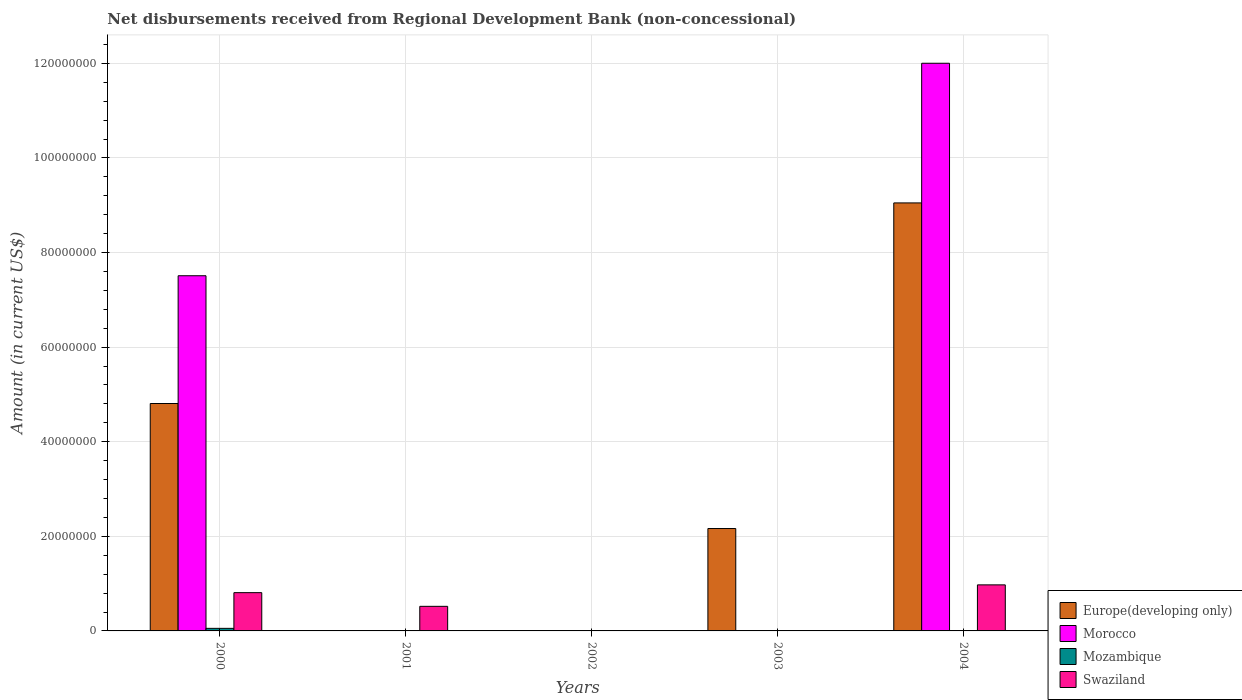How many different coloured bars are there?
Your answer should be very brief. 4. Are the number of bars per tick equal to the number of legend labels?
Your answer should be compact. No. How many bars are there on the 3rd tick from the left?
Keep it short and to the point. 0. How many bars are there on the 3rd tick from the right?
Offer a very short reply. 0. What is the label of the 1st group of bars from the left?
Offer a very short reply. 2000. In how many cases, is the number of bars for a given year not equal to the number of legend labels?
Give a very brief answer. 4. What is the amount of disbursements received from Regional Development Bank in Morocco in 2000?
Make the answer very short. 7.51e+07. Across all years, what is the maximum amount of disbursements received from Regional Development Bank in Swaziland?
Offer a terse response. 9.74e+06. Across all years, what is the minimum amount of disbursements received from Regional Development Bank in Swaziland?
Provide a short and direct response. 0. What is the total amount of disbursements received from Regional Development Bank in Europe(developing only) in the graph?
Offer a terse response. 1.60e+08. What is the difference between the amount of disbursements received from Regional Development Bank in Europe(developing only) in 2000 and that in 2004?
Make the answer very short. -4.24e+07. What is the difference between the amount of disbursements received from Regional Development Bank in Morocco in 2000 and the amount of disbursements received from Regional Development Bank in Swaziland in 2003?
Provide a short and direct response. 7.51e+07. What is the average amount of disbursements received from Regional Development Bank in Morocco per year?
Give a very brief answer. 3.90e+07. In the year 2000, what is the difference between the amount of disbursements received from Regional Development Bank in Morocco and amount of disbursements received from Regional Development Bank in Europe(developing only)?
Your answer should be very brief. 2.70e+07. In how many years, is the amount of disbursements received from Regional Development Bank in Swaziland greater than 32000000 US$?
Make the answer very short. 0. What is the ratio of the amount of disbursements received from Regional Development Bank in Europe(developing only) in 2003 to that in 2004?
Ensure brevity in your answer.  0.24. Is the amount of disbursements received from Regional Development Bank in Morocco in 2000 less than that in 2004?
Keep it short and to the point. Yes. What is the difference between the highest and the second highest amount of disbursements received from Regional Development Bank in Swaziland?
Provide a succinct answer. 1.65e+06. What is the difference between the highest and the lowest amount of disbursements received from Regional Development Bank in Swaziland?
Offer a very short reply. 9.74e+06. In how many years, is the amount of disbursements received from Regional Development Bank in Mozambique greater than the average amount of disbursements received from Regional Development Bank in Mozambique taken over all years?
Your response must be concise. 1. Is the sum of the amount of disbursements received from Regional Development Bank in Swaziland in 2000 and 2001 greater than the maximum amount of disbursements received from Regional Development Bank in Europe(developing only) across all years?
Make the answer very short. No. Is it the case that in every year, the sum of the amount of disbursements received from Regional Development Bank in Morocco and amount of disbursements received from Regional Development Bank in Europe(developing only) is greater than the sum of amount of disbursements received from Regional Development Bank in Mozambique and amount of disbursements received from Regional Development Bank in Swaziland?
Provide a short and direct response. No. How many years are there in the graph?
Give a very brief answer. 5. What is the difference between two consecutive major ticks on the Y-axis?
Offer a terse response. 2.00e+07. Are the values on the major ticks of Y-axis written in scientific E-notation?
Offer a terse response. No. Does the graph contain any zero values?
Provide a short and direct response. Yes. Does the graph contain grids?
Provide a short and direct response. Yes. How many legend labels are there?
Keep it short and to the point. 4. How are the legend labels stacked?
Make the answer very short. Vertical. What is the title of the graph?
Ensure brevity in your answer.  Net disbursements received from Regional Development Bank (non-concessional). What is the label or title of the X-axis?
Your response must be concise. Years. What is the Amount (in current US$) of Europe(developing only) in 2000?
Your answer should be compact. 4.81e+07. What is the Amount (in current US$) of Morocco in 2000?
Provide a short and direct response. 7.51e+07. What is the Amount (in current US$) in Mozambique in 2000?
Keep it short and to the point. 5.43e+05. What is the Amount (in current US$) of Swaziland in 2000?
Your answer should be compact. 8.09e+06. What is the Amount (in current US$) of Europe(developing only) in 2001?
Provide a succinct answer. 0. What is the Amount (in current US$) in Morocco in 2001?
Your answer should be compact. 0. What is the Amount (in current US$) in Mozambique in 2001?
Provide a succinct answer. 0. What is the Amount (in current US$) in Swaziland in 2001?
Ensure brevity in your answer.  5.20e+06. What is the Amount (in current US$) of Europe(developing only) in 2003?
Make the answer very short. 2.16e+07. What is the Amount (in current US$) in Europe(developing only) in 2004?
Keep it short and to the point. 9.05e+07. What is the Amount (in current US$) in Morocco in 2004?
Offer a terse response. 1.20e+08. What is the Amount (in current US$) of Swaziland in 2004?
Your answer should be compact. 9.74e+06. Across all years, what is the maximum Amount (in current US$) of Europe(developing only)?
Your answer should be very brief. 9.05e+07. Across all years, what is the maximum Amount (in current US$) in Morocco?
Provide a succinct answer. 1.20e+08. Across all years, what is the maximum Amount (in current US$) of Mozambique?
Your answer should be compact. 5.43e+05. Across all years, what is the maximum Amount (in current US$) in Swaziland?
Offer a very short reply. 9.74e+06. Across all years, what is the minimum Amount (in current US$) of Mozambique?
Provide a short and direct response. 0. What is the total Amount (in current US$) in Europe(developing only) in the graph?
Give a very brief answer. 1.60e+08. What is the total Amount (in current US$) in Morocco in the graph?
Give a very brief answer. 1.95e+08. What is the total Amount (in current US$) in Mozambique in the graph?
Make the answer very short. 5.43e+05. What is the total Amount (in current US$) of Swaziland in the graph?
Make the answer very short. 2.30e+07. What is the difference between the Amount (in current US$) in Swaziland in 2000 and that in 2001?
Your answer should be very brief. 2.89e+06. What is the difference between the Amount (in current US$) of Europe(developing only) in 2000 and that in 2003?
Your answer should be very brief. 2.64e+07. What is the difference between the Amount (in current US$) of Europe(developing only) in 2000 and that in 2004?
Keep it short and to the point. -4.24e+07. What is the difference between the Amount (in current US$) of Morocco in 2000 and that in 2004?
Offer a very short reply. -4.49e+07. What is the difference between the Amount (in current US$) of Swaziland in 2000 and that in 2004?
Your response must be concise. -1.65e+06. What is the difference between the Amount (in current US$) in Swaziland in 2001 and that in 2004?
Offer a terse response. -4.54e+06. What is the difference between the Amount (in current US$) of Europe(developing only) in 2003 and that in 2004?
Provide a succinct answer. -6.88e+07. What is the difference between the Amount (in current US$) of Europe(developing only) in 2000 and the Amount (in current US$) of Swaziland in 2001?
Offer a terse response. 4.29e+07. What is the difference between the Amount (in current US$) of Morocco in 2000 and the Amount (in current US$) of Swaziland in 2001?
Offer a terse response. 6.99e+07. What is the difference between the Amount (in current US$) of Mozambique in 2000 and the Amount (in current US$) of Swaziland in 2001?
Your answer should be compact. -4.66e+06. What is the difference between the Amount (in current US$) in Europe(developing only) in 2000 and the Amount (in current US$) in Morocco in 2004?
Give a very brief answer. -7.19e+07. What is the difference between the Amount (in current US$) of Europe(developing only) in 2000 and the Amount (in current US$) of Swaziland in 2004?
Ensure brevity in your answer.  3.83e+07. What is the difference between the Amount (in current US$) of Morocco in 2000 and the Amount (in current US$) of Swaziland in 2004?
Ensure brevity in your answer.  6.54e+07. What is the difference between the Amount (in current US$) of Mozambique in 2000 and the Amount (in current US$) of Swaziland in 2004?
Provide a succinct answer. -9.20e+06. What is the difference between the Amount (in current US$) in Europe(developing only) in 2003 and the Amount (in current US$) in Morocco in 2004?
Your answer should be very brief. -9.84e+07. What is the difference between the Amount (in current US$) of Europe(developing only) in 2003 and the Amount (in current US$) of Swaziland in 2004?
Provide a succinct answer. 1.19e+07. What is the average Amount (in current US$) of Europe(developing only) per year?
Make the answer very short. 3.20e+07. What is the average Amount (in current US$) of Morocco per year?
Offer a very short reply. 3.90e+07. What is the average Amount (in current US$) in Mozambique per year?
Make the answer very short. 1.09e+05. What is the average Amount (in current US$) in Swaziland per year?
Your answer should be very brief. 4.61e+06. In the year 2000, what is the difference between the Amount (in current US$) of Europe(developing only) and Amount (in current US$) of Morocco?
Ensure brevity in your answer.  -2.70e+07. In the year 2000, what is the difference between the Amount (in current US$) in Europe(developing only) and Amount (in current US$) in Mozambique?
Provide a short and direct response. 4.75e+07. In the year 2000, what is the difference between the Amount (in current US$) in Europe(developing only) and Amount (in current US$) in Swaziland?
Provide a succinct answer. 4.00e+07. In the year 2000, what is the difference between the Amount (in current US$) of Morocco and Amount (in current US$) of Mozambique?
Your response must be concise. 7.46e+07. In the year 2000, what is the difference between the Amount (in current US$) in Morocco and Amount (in current US$) in Swaziland?
Keep it short and to the point. 6.70e+07. In the year 2000, what is the difference between the Amount (in current US$) of Mozambique and Amount (in current US$) of Swaziland?
Ensure brevity in your answer.  -7.55e+06. In the year 2004, what is the difference between the Amount (in current US$) of Europe(developing only) and Amount (in current US$) of Morocco?
Ensure brevity in your answer.  -2.95e+07. In the year 2004, what is the difference between the Amount (in current US$) of Europe(developing only) and Amount (in current US$) of Swaziland?
Provide a succinct answer. 8.08e+07. In the year 2004, what is the difference between the Amount (in current US$) of Morocco and Amount (in current US$) of Swaziland?
Offer a very short reply. 1.10e+08. What is the ratio of the Amount (in current US$) in Swaziland in 2000 to that in 2001?
Offer a terse response. 1.56. What is the ratio of the Amount (in current US$) in Europe(developing only) in 2000 to that in 2003?
Offer a very short reply. 2.22. What is the ratio of the Amount (in current US$) of Europe(developing only) in 2000 to that in 2004?
Give a very brief answer. 0.53. What is the ratio of the Amount (in current US$) of Morocco in 2000 to that in 2004?
Ensure brevity in your answer.  0.63. What is the ratio of the Amount (in current US$) of Swaziland in 2000 to that in 2004?
Ensure brevity in your answer.  0.83. What is the ratio of the Amount (in current US$) of Swaziland in 2001 to that in 2004?
Your answer should be very brief. 0.53. What is the ratio of the Amount (in current US$) in Europe(developing only) in 2003 to that in 2004?
Your answer should be compact. 0.24. What is the difference between the highest and the second highest Amount (in current US$) of Europe(developing only)?
Offer a very short reply. 4.24e+07. What is the difference between the highest and the second highest Amount (in current US$) of Swaziland?
Provide a short and direct response. 1.65e+06. What is the difference between the highest and the lowest Amount (in current US$) in Europe(developing only)?
Ensure brevity in your answer.  9.05e+07. What is the difference between the highest and the lowest Amount (in current US$) of Morocco?
Give a very brief answer. 1.20e+08. What is the difference between the highest and the lowest Amount (in current US$) in Mozambique?
Your answer should be very brief. 5.43e+05. What is the difference between the highest and the lowest Amount (in current US$) in Swaziland?
Make the answer very short. 9.74e+06. 